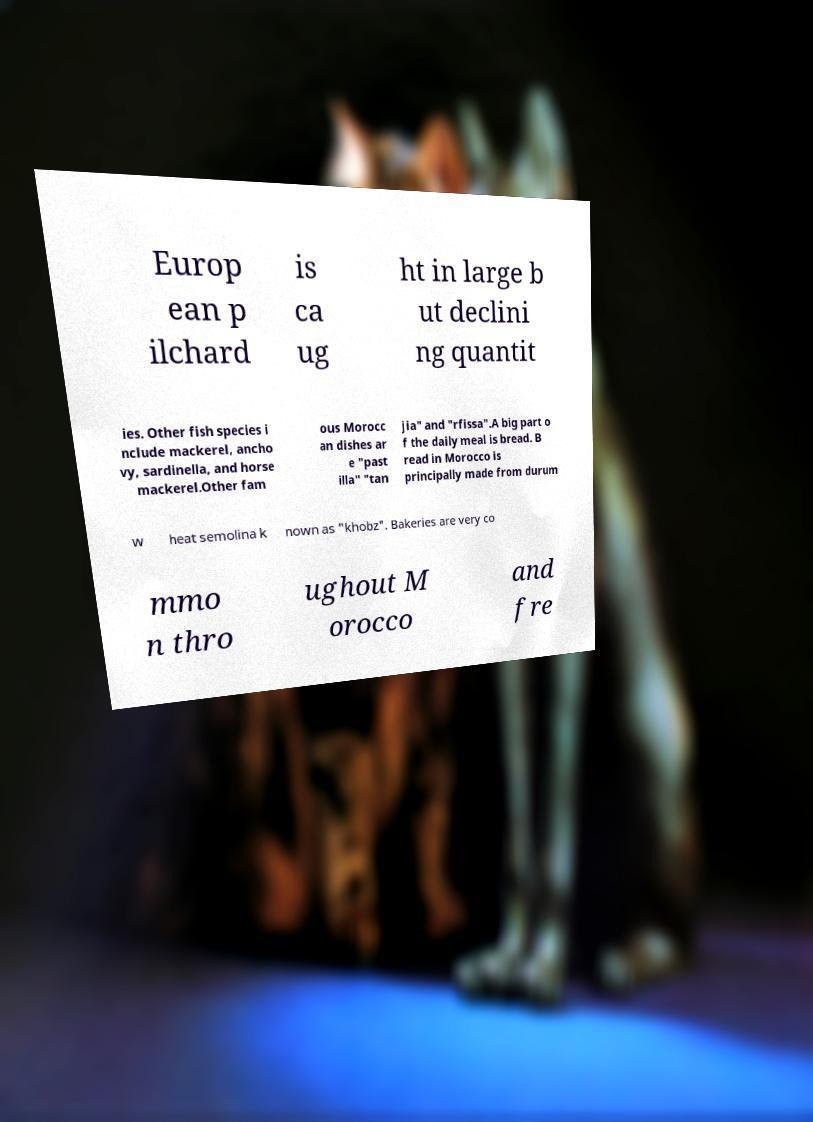Can you accurately transcribe the text from the provided image for me? Europ ean p ilchard is ca ug ht in large b ut declini ng quantit ies. Other fish species i nclude mackerel, ancho vy, sardinella, and horse mackerel.Other fam ous Morocc an dishes ar e "past illa" "tan jia" and "rfissa".A big part o f the daily meal is bread. B read in Morocco is principally made from durum w heat semolina k nown as "khobz". Bakeries are very co mmo n thro ughout M orocco and fre 